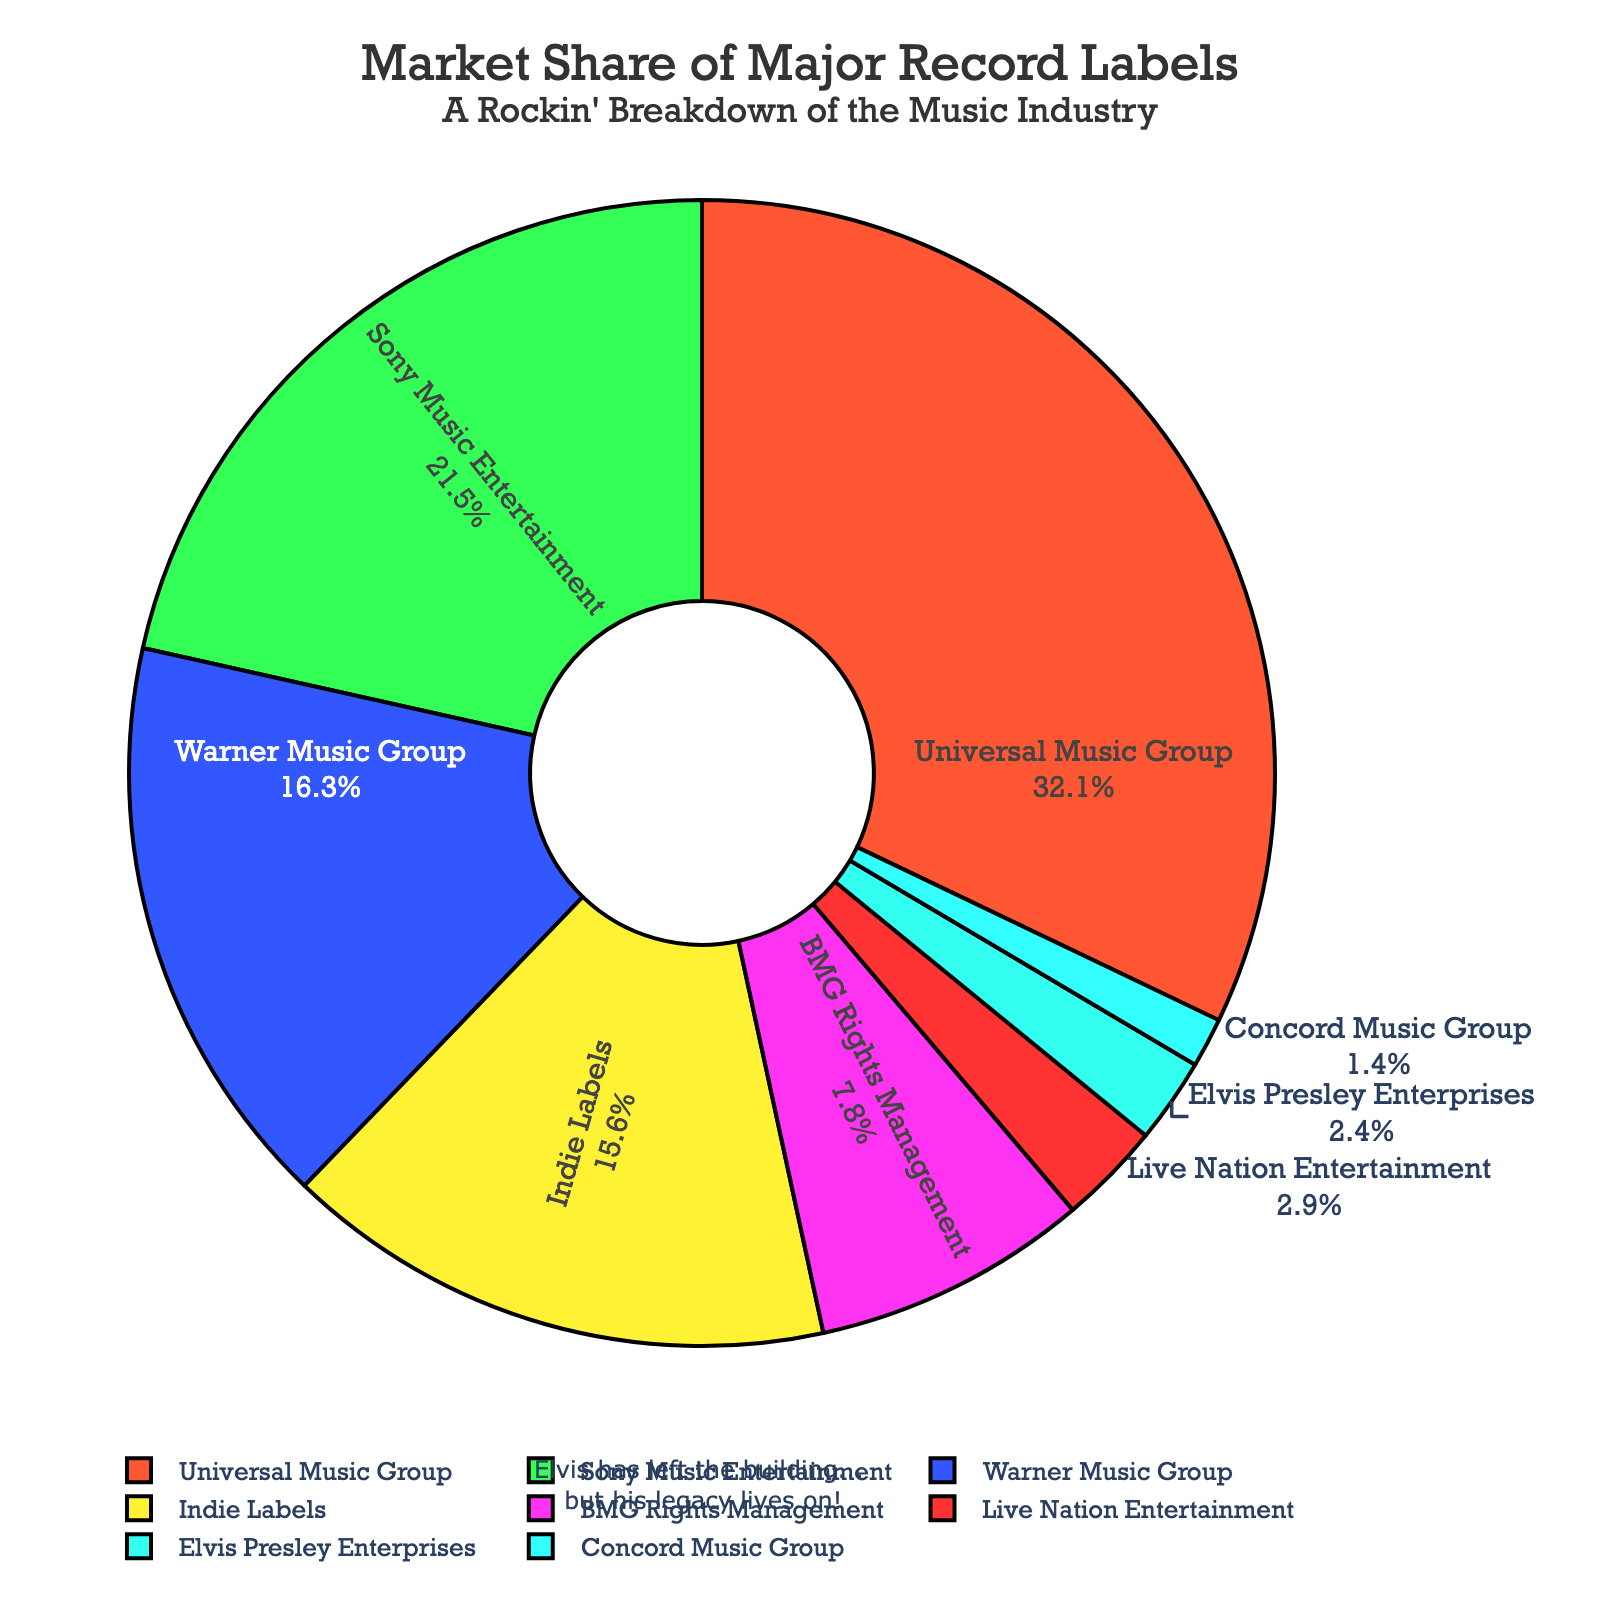How much higher is Universal Music Group's market share compared to Sony Music Entertainment? Universal Music Group's market share is 32.1%, while Sony Music Entertainment's is 21.5%. The difference is 32.1% - 21.5%.
Answer: 10.6% What is the combined market share of Elvis Presley Enterprises and Indie Labels? The market share of Elvis Presley Enterprises is 2.4%, and Indie Labels is 15.6%. Their combined market share is 2.4% + 15.6%.
Answer: 18% Which record label has the smallest market share, and what is that share? By looking at the pie chart, the color region with the smallest slice represents Concord Music Group. The market share for Concord Music Group is 1.4%.
Answer: Concord Music Group, 1.4% Is Live Nation Entertainment's market share greater than BMG Rights Management's market share? Live Nation Entertainment's market share is 2.9%, while BMG Rights Management's market share is 7.8%. Comparing these values, 2.9% is less than 7.8%.
Answer: No How much more market share does Warner Music Group have compared to Live Nation Entertainment and Concord Music Group combined? Warner Music Group's market share is 16.3%. Live Nation Entertainment's market share is 2.9% and Concord Music Group's is 1.4%, so their combined share is 2.9% + 1.4% = 4.3%. The difference is 16.3% - 4.3%.
Answer: 12% Among the labels with a market share below 10%, which one has the highest share? By inspecting the slices of the pie chart for labels with market shares below 10%, BMG Rights Management has the highest share at 7.8%.
Answer: BMG Rights Management What percentage of the market share is held by labels other than the top three (Universal Music Group, Sony Music Entertainment, and Warner Music Group)? The total market share is 100%. The top three labels' market shares are 32.1%, 21.5%, and 16.3%. Summing these gives 32.1% + 21.5% + 16.3% = 69.9%. Subtracting from 100% gives 100% - 69.9%.
Answer: 30.1% Which record label’s market share is represented by the slice with the bright green color? According to the color palette in the code review, the bright green color corresponds to Sony Music Entertainment.
Answer: Sony Music Entertainment 